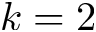Convert formula to latex. <formula><loc_0><loc_0><loc_500><loc_500>k = 2</formula> 